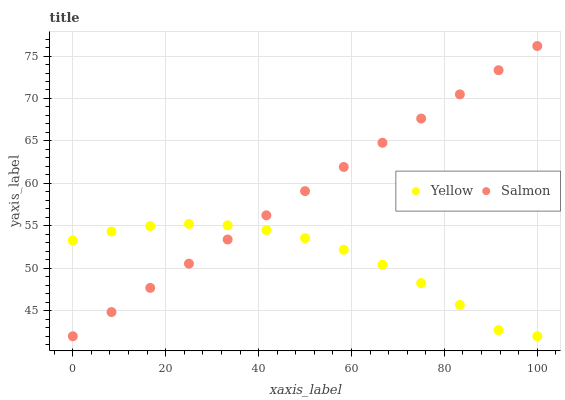Does Yellow have the minimum area under the curve?
Answer yes or no. Yes. Does Salmon have the maximum area under the curve?
Answer yes or no. Yes. Does Yellow have the maximum area under the curve?
Answer yes or no. No. Is Salmon the smoothest?
Answer yes or no. Yes. Is Yellow the roughest?
Answer yes or no. Yes. Is Yellow the smoothest?
Answer yes or no. No. Does Salmon have the lowest value?
Answer yes or no. Yes. Does Salmon have the highest value?
Answer yes or no. Yes. Does Yellow have the highest value?
Answer yes or no. No. Does Yellow intersect Salmon?
Answer yes or no. Yes. Is Yellow less than Salmon?
Answer yes or no. No. Is Yellow greater than Salmon?
Answer yes or no. No. 